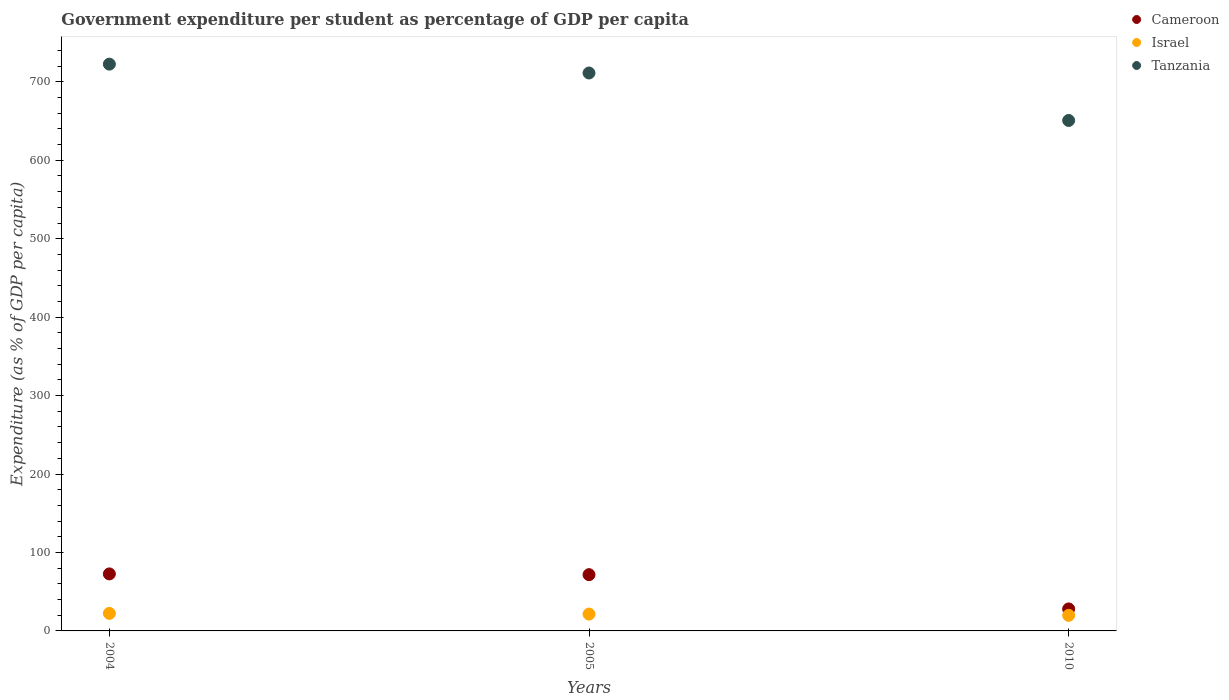Is the number of dotlines equal to the number of legend labels?
Make the answer very short. Yes. What is the percentage of expenditure per student in Cameroon in 2005?
Your answer should be very brief. 71.72. Across all years, what is the maximum percentage of expenditure per student in Cameroon?
Your answer should be compact. 72.69. Across all years, what is the minimum percentage of expenditure per student in Tanzania?
Your answer should be compact. 650.78. What is the total percentage of expenditure per student in Israel in the graph?
Your answer should be compact. 63.69. What is the difference between the percentage of expenditure per student in Tanzania in 2004 and that in 2005?
Provide a short and direct response. 11.29. What is the difference between the percentage of expenditure per student in Cameroon in 2004 and the percentage of expenditure per student in Israel in 2005?
Your answer should be very brief. 51.23. What is the average percentage of expenditure per student in Tanzania per year?
Offer a terse response. 694.89. In the year 2004, what is the difference between the percentage of expenditure per student in Cameroon and percentage of expenditure per student in Tanzania?
Give a very brief answer. -649.91. In how many years, is the percentage of expenditure per student in Cameroon greater than 520 %?
Offer a very short reply. 0. What is the ratio of the percentage of expenditure per student in Tanzania in 2005 to that in 2010?
Your answer should be very brief. 1.09. Is the percentage of expenditure per student in Israel in 2004 less than that in 2010?
Your answer should be compact. No. Is the difference between the percentage of expenditure per student in Cameroon in 2005 and 2010 greater than the difference between the percentage of expenditure per student in Tanzania in 2005 and 2010?
Give a very brief answer. No. What is the difference between the highest and the second highest percentage of expenditure per student in Cameroon?
Give a very brief answer. 0.97. What is the difference between the highest and the lowest percentage of expenditure per student in Tanzania?
Your response must be concise. 71.81. In how many years, is the percentage of expenditure per student in Tanzania greater than the average percentage of expenditure per student in Tanzania taken over all years?
Provide a short and direct response. 2. Is it the case that in every year, the sum of the percentage of expenditure per student in Tanzania and percentage of expenditure per student in Cameroon  is greater than the percentage of expenditure per student in Israel?
Provide a succinct answer. Yes. Does the percentage of expenditure per student in Israel monotonically increase over the years?
Give a very brief answer. No. Is the percentage of expenditure per student in Israel strictly greater than the percentage of expenditure per student in Tanzania over the years?
Make the answer very short. No. Is the percentage of expenditure per student in Cameroon strictly less than the percentage of expenditure per student in Tanzania over the years?
Offer a terse response. Yes. How many dotlines are there?
Your answer should be very brief. 3. How many years are there in the graph?
Provide a succinct answer. 3. What is the difference between two consecutive major ticks on the Y-axis?
Your answer should be compact. 100. Are the values on the major ticks of Y-axis written in scientific E-notation?
Give a very brief answer. No. Does the graph contain grids?
Provide a succinct answer. No. Where does the legend appear in the graph?
Make the answer very short. Top right. How many legend labels are there?
Make the answer very short. 3. What is the title of the graph?
Provide a succinct answer. Government expenditure per student as percentage of GDP per capita. What is the label or title of the Y-axis?
Your answer should be compact. Expenditure (as % of GDP per capita). What is the Expenditure (as % of GDP per capita) of Cameroon in 2004?
Provide a succinct answer. 72.69. What is the Expenditure (as % of GDP per capita) of Israel in 2004?
Offer a very short reply. 22.37. What is the Expenditure (as % of GDP per capita) in Tanzania in 2004?
Provide a short and direct response. 722.6. What is the Expenditure (as % of GDP per capita) in Cameroon in 2005?
Ensure brevity in your answer.  71.72. What is the Expenditure (as % of GDP per capita) of Israel in 2005?
Your answer should be very brief. 21.46. What is the Expenditure (as % of GDP per capita) in Tanzania in 2005?
Offer a very short reply. 711.3. What is the Expenditure (as % of GDP per capita) of Cameroon in 2010?
Ensure brevity in your answer.  28.04. What is the Expenditure (as % of GDP per capita) of Israel in 2010?
Your answer should be very brief. 19.86. What is the Expenditure (as % of GDP per capita) in Tanzania in 2010?
Your answer should be compact. 650.78. Across all years, what is the maximum Expenditure (as % of GDP per capita) in Cameroon?
Your answer should be compact. 72.69. Across all years, what is the maximum Expenditure (as % of GDP per capita) in Israel?
Your answer should be compact. 22.37. Across all years, what is the maximum Expenditure (as % of GDP per capita) in Tanzania?
Your response must be concise. 722.6. Across all years, what is the minimum Expenditure (as % of GDP per capita) of Cameroon?
Offer a very short reply. 28.04. Across all years, what is the minimum Expenditure (as % of GDP per capita) in Israel?
Provide a short and direct response. 19.86. Across all years, what is the minimum Expenditure (as % of GDP per capita) of Tanzania?
Keep it short and to the point. 650.78. What is the total Expenditure (as % of GDP per capita) in Cameroon in the graph?
Offer a terse response. 172.45. What is the total Expenditure (as % of GDP per capita) of Israel in the graph?
Give a very brief answer. 63.69. What is the total Expenditure (as % of GDP per capita) of Tanzania in the graph?
Make the answer very short. 2084.68. What is the difference between the Expenditure (as % of GDP per capita) in Cameroon in 2004 and that in 2005?
Provide a succinct answer. 0.97. What is the difference between the Expenditure (as % of GDP per capita) in Israel in 2004 and that in 2005?
Your answer should be very brief. 0.91. What is the difference between the Expenditure (as % of GDP per capita) of Tanzania in 2004 and that in 2005?
Offer a very short reply. 11.29. What is the difference between the Expenditure (as % of GDP per capita) in Cameroon in 2004 and that in 2010?
Make the answer very short. 44.65. What is the difference between the Expenditure (as % of GDP per capita) in Israel in 2004 and that in 2010?
Give a very brief answer. 2.51. What is the difference between the Expenditure (as % of GDP per capita) of Tanzania in 2004 and that in 2010?
Ensure brevity in your answer.  71.81. What is the difference between the Expenditure (as % of GDP per capita) in Cameroon in 2005 and that in 2010?
Your answer should be very brief. 43.67. What is the difference between the Expenditure (as % of GDP per capita) in Israel in 2005 and that in 2010?
Your response must be concise. 1.6. What is the difference between the Expenditure (as % of GDP per capita) of Tanzania in 2005 and that in 2010?
Provide a short and direct response. 60.52. What is the difference between the Expenditure (as % of GDP per capita) of Cameroon in 2004 and the Expenditure (as % of GDP per capita) of Israel in 2005?
Give a very brief answer. 51.23. What is the difference between the Expenditure (as % of GDP per capita) of Cameroon in 2004 and the Expenditure (as % of GDP per capita) of Tanzania in 2005?
Keep it short and to the point. -638.61. What is the difference between the Expenditure (as % of GDP per capita) in Israel in 2004 and the Expenditure (as % of GDP per capita) in Tanzania in 2005?
Ensure brevity in your answer.  -688.93. What is the difference between the Expenditure (as % of GDP per capita) of Cameroon in 2004 and the Expenditure (as % of GDP per capita) of Israel in 2010?
Make the answer very short. 52.83. What is the difference between the Expenditure (as % of GDP per capita) of Cameroon in 2004 and the Expenditure (as % of GDP per capita) of Tanzania in 2010?
Provide a short and direct response. -578.09. What is the difference between the Expenditure (as % of GDP per capita) of Israel in 2004 and the Expenditure (as % of GDP per capita) of Tanzania in 2010?
Offer a very short reply. -628.41. What is the difference between the Expenditure (as % of GDP per capita) of Cameroon in 2005 and the Expenditure (as % of GDP per capita) of Israel in 2010?
Offer a very short reply. 51.86. What is the difference between the Expenditure (as % of GDP per capita) in Cameroon in 2005 and the Expenditure (as % of GDP per capita) in Tanzania in 2010?
Keep it short and to the point. -579.06. What is the difference between the Expenditure (as % of GDP per capita) of Israel in 2005 and the Expenditure (as % of GDP per capita) of Tanzania in 2010?
Provide a succinct answer. -629.32. What is the average Expenditure (as % of GDP per capita) in Cameroon per year?
Your answer should be compact. 57.48. What is the average Expenditure (as % of GDP per capita) of Israel per year?
Give a very brief answer. 21.23. What is the average Expenditure (as % of GDP per capita) of Tanzania per year?
Give a very brief answer. 694.89. In the year 2004, what is the difference between the Expenditure (as % of GDP per capita) of Cameroon and Expenditure (as % of GDP per capita) of Israel?
Ensure brevity in your answer.  50.32. In the year 2004, what is the difference between the Expenditure (as % of GDP per capita) of Cameroon and Expenditure (as % of GDP per capita) of Tanzania?
Offer a terse response. -649.91. In the year 2004, what is the difference between the Expenditure (as % of GDP per capita) in Israel and Expenditure (as % of GDP per capita) in Tanzania?
Ensure brevity in your answer.  -700.23. In the year 2005, what is the difference between the Expenditure (as % of GDP per capita) in Cameroon and Expenditure (as % of GDP per capita) in Israel?
Ensure brevity in your answer.  50.26. In the year 2005, what is the difference between the Expenditure (as % of GDP per capita) in Cameroon and Expenditure (as % of GDP per capita) in Tanzania?
Your answer should be very brief. -639.58. In the year 2005, what is the difference between the Expenditure (as % of GDP per capita) in Israel and Expenditure (as % of GDP per capita) in Tanzania?
Give a very brief answer. -689.84. In the year 2010, what is the difference between the Expenditure (as % of GDP per capita) in Cameroon and Expenditure (as % of GDP per capita) in Israel?
Offer a terse response. 8.18. In the year 2010, what is the difference between the Expenditure (as % of GDP per capita) in Cameroon and Expenditure (as % of GDP per capita) in Tanzania?
Make the answer very short. -622.74. In the year 2010, what is the difference between the Expenditure (as % of GDP per capita) of Israel and Expenditure (as % of GDP per capita) of Tanzania?
Make the answer very short. -630.92. What is the ratio of the Expenditure (as % of GDP per capita) in Cameroon in 2004 to that in 2005?
Make the answer very short. 1.01. What is the ratio of the Expenditure (as % of GDP per capita) in Israel in 2004 to that in 2005?
Your answer should be compact. 1.04. What is the ratio of the Expenditure (as % of GDP per capita) in Tanzania in 2004 to that in 2005?
Make the answer very short. 1.02. What is the ratio of the Expenditure (as % of GDP per capita) in Cameroon in 2004 to that in 2010?
Your response must be concise. 2.59. What is the ratio of the Expenditure (as % of GDP per capita) of Israel in 2004 to that in 2010?
Make the answer very short. 1.13. What is the ratio of the Expenditure (as % of GDP per capita) in Tanzania in 2004 to that in 2010?
Your answer should be compact. 1.11. What is the ratio of the Expenditure (as % of GDP per capita) of Cameroon in 2005 to that in 2010?
Your answer should be compact. 2.56. What is the ratio of the Expenditure (as % of GDP per capita) of Israel in 2005 to that in 2010?
Your response must be concise. 1.08. What is the ratio of the Expenditure (as % of GDP per capita) in Tanzania in 2005 to that in 2010?
Provide a short and direct response. 1.09. What is the difference between the highest and the second highest Expenditure (as % of GDP per capita) of Cameroon?
Provide a succinct answer. 0.97. What is the difference between the highest and the second highest Expenditure (as % of GDP per capita) of Israel?
Provide a short and direct response. 0.91. What is the difference between the highest and the second highest Expenditure (as % of GDP per capita) in Tanzania?
Ensure brevity in your answer.  11.29. What is the difference between the highest and the lowest Expenditure (as % of GDP per capita) of Cameroon?
Your answer should be very brief. 44.65. What is the difference between the highest and the lowest Expenditure (as % of GDP per capita) of Israel?
Give a very brief answer. 2.51. What is the difference between the highest and the lowest Expenditure (as % of GDP per capita) of Tanzania?
Your response must be concise. 71.81. 